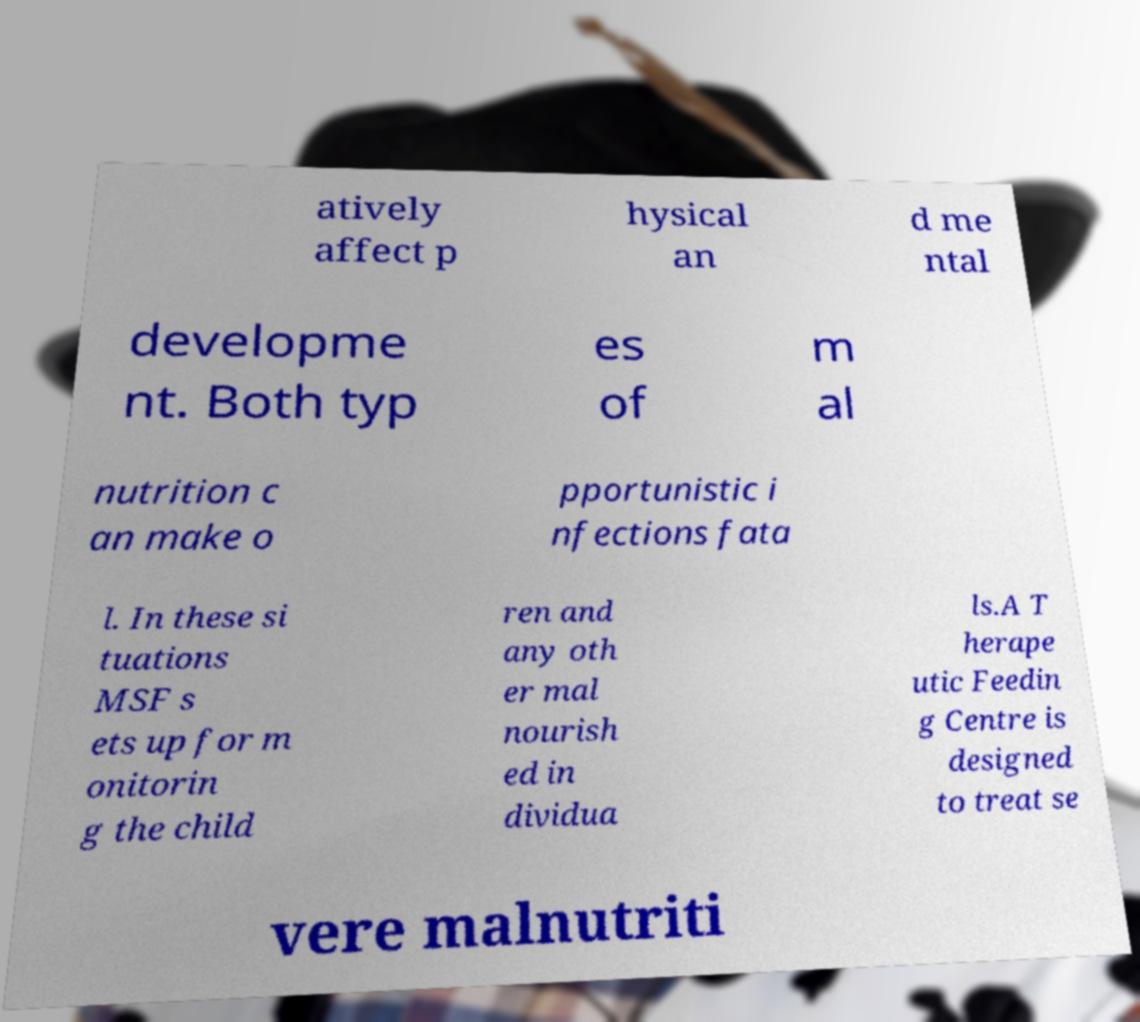Could you assist in decoding the text presented in this image and type it out clearly? atively affect p hysical an d me ntal developme nt. Both typ es of m al nutrition c an make o pportunistic i nfections fata l. In these si tuations MSF s ets up for m onitorin g the child ren and any oth er mal nourish ed in dividua ls.A T herape utic Feedin g Centre is designed to treat se vere malnutriti 